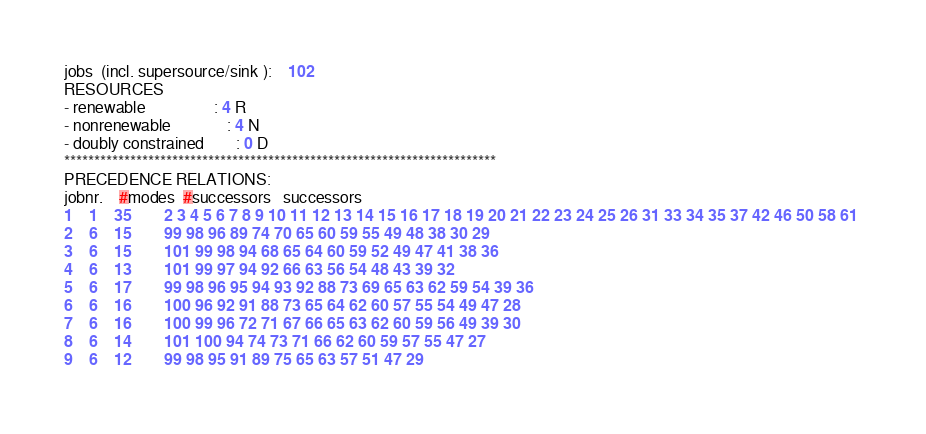<code> <loc_0><loc_0><loc_500><loc_500><_ObjectiveC_>jobs  (incl. supersource/sink ):	102
RESOURCES
- renewable                 : 4 R
- nonrenewable              : 4 N
- doubly constrained        : 0 D
************************************************************************
PRECEDENCE RELATIONS:
jobnr.    #modes  #successors   successors
1	1	35		2 3 4 5 6 7 8 9 10 11 12 13 14 15 16 17 18 19 20 21 22 23 24 25 26 31 33 34 35 37 42 46 50 58 61 
2	6	15		99 98 96 89 74 70 65 60 59 55 49 48 38 30 29 
3	6	15		101 99 98 94 68 65 64 60 59 52 49 47 41 38 36 
4	6	13		101 99 97 94 92 66 63 56 54 48 43 39 32 
5	6	17		99 98 96 95 94 93 92 88 73 69 65 63 62 59 54 39 36 
6	6	16		100 96 92 91 88 73 65 64 62 60 57 55 54 49 47 28 
7	6	16		100 99 96 72 71 67 66 65 63 62 60 59 56 49 39 30 
8	6	14		101 100 94 74 73 71 66 62 60 59 57 55 47 27 
9	6	12		99 98 95 91 89 75 65 63 57 51 47 29 </code> 